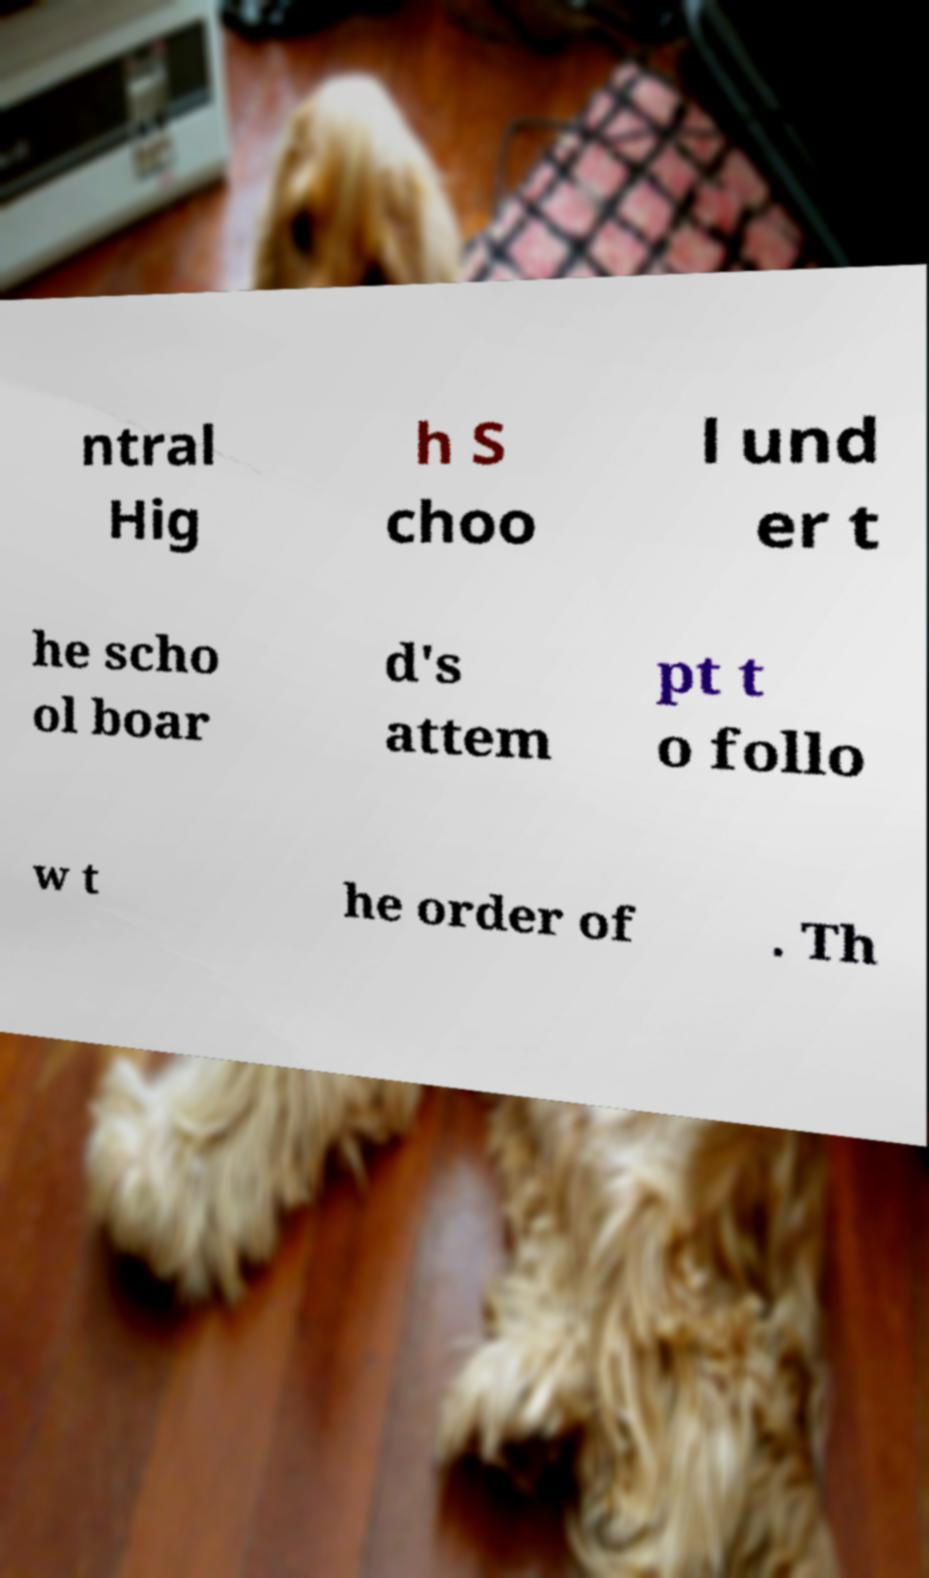Can you read and provide the text displayed in the image?This photo seems to have some interesting text. Can you extract and type it out for me? ntral Hig h S choo l und er t he scho ol boar d's attem pt t o follo w t he order of . Th 